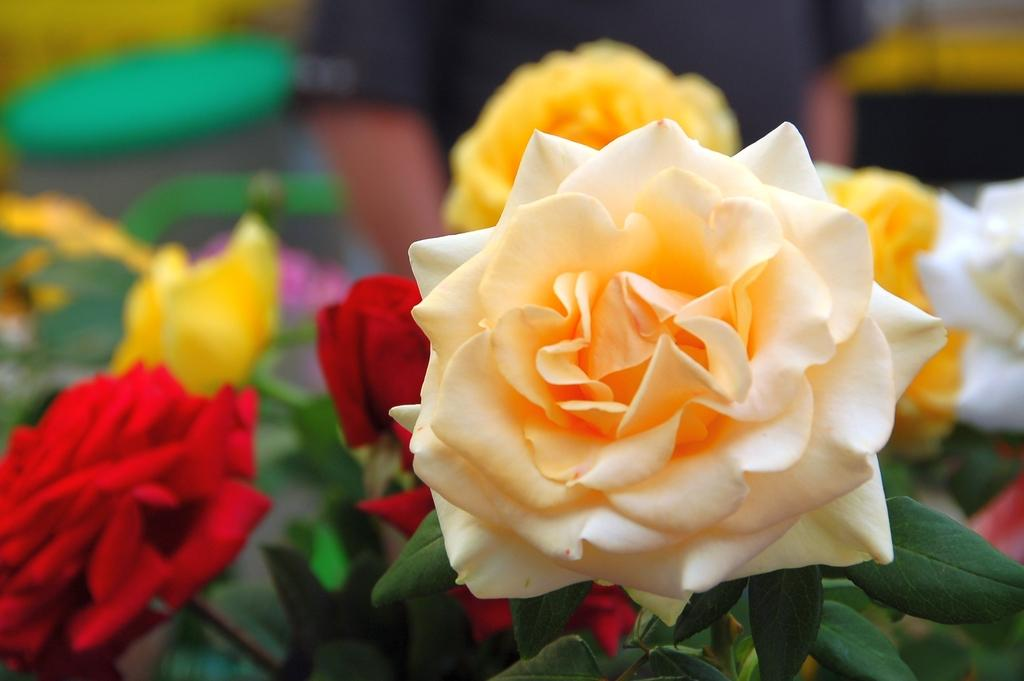What type of plant is in the image? The image contains a plant with roses. What colors can be seen on the roses? The roses have cream, red, yellow, and white colors. How is the background of the image depicted? The background of the image is blurred. What type of alarm can be heard going off in the image? There is no alarm present in the image, as it is a still photograph of a plant with roses. What flavor of mint is associated with the plant in the image? The image does not depict a mint plant, so there is no mint flavor associated with it. 